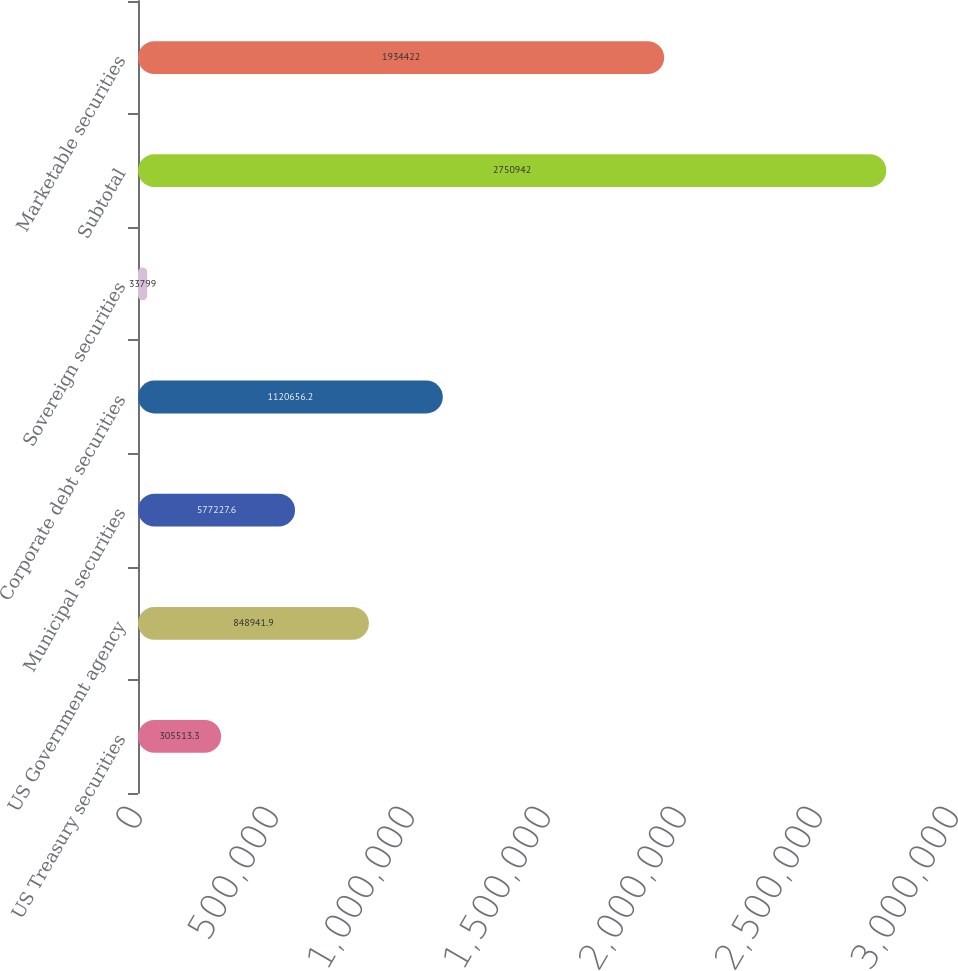<chart> <loc_0><loc_0><loc_500><loc_500><bar_chart><fcel>US Treasury securities<fcel>US Government agency<fcel>Municipal securities<fcel>Corporate debt securities<fcel>Sovereign securities<fcel>Subtotal<fcel>Marketable securities<nl><fcel>305513<fcel>848942<fcel>577228<fcel>1.12066e+06<fcel>33799<fcel>2.75094e+06<fcel>1.93442e+06<nl></chart> 